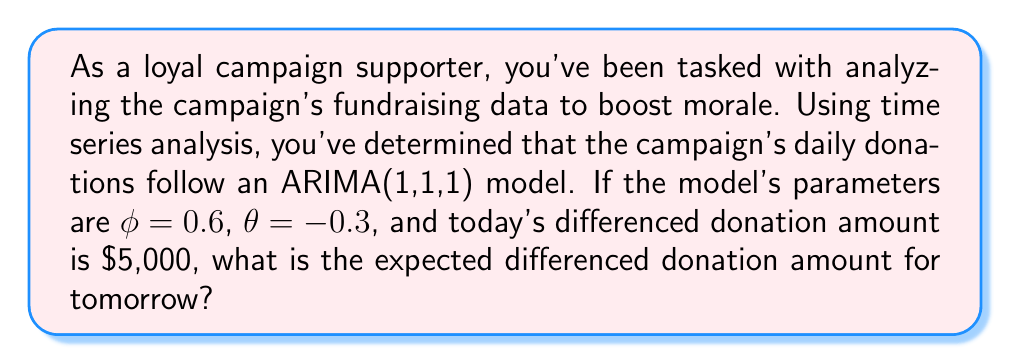Can you answer this question? Let's approach this step-by-step:

1) The ARIMA(1,1,1) model for the differenced series can be written as:

   $$(1 - \phi B)(1-B)X_t = (1 + \theta B)\epsilon_t$$

   where $B$ is the backshift operator, $X_t$ is the original series, and $\epsilon_t$ is white noise.

2) For forecasting one step ahead, we use the equation:

   $$\hat{X}_{t+1} - X_t = \phi(X_t - X_{t-1}) + \epsilon_t + \theta\epsilon_{t-1}$$

3) Let $Y_t = X_t - X_{t-1}$ be the differenced series. Then our forecast equation becomes:

   $$\hat{Y}_{t+1} = \phi Y_t + \epsilon_t + \theta\epsilon_{t-1}$$

4) We're given that $\phi = 0.6$ and $\theta = -0.3$. Also, $Y_t = \$5,000$.

5) For forecasting, we assume future errors are zero: $\epsilon_{t+1} = 0$.

6) We don't know the exact values of $\epsilon_t$ and $\epsilon_{t-1}$, but their expected value is zero.

7) Therefore, our forecast becomes:

   $$\hat{Y}_{t+1} = \phi Y_t = 0.6 \times \$5,000 = \$3,000$$

Thus, the expected differenced donation amount for tomorrow is $3,000.
Answer: $3,000 